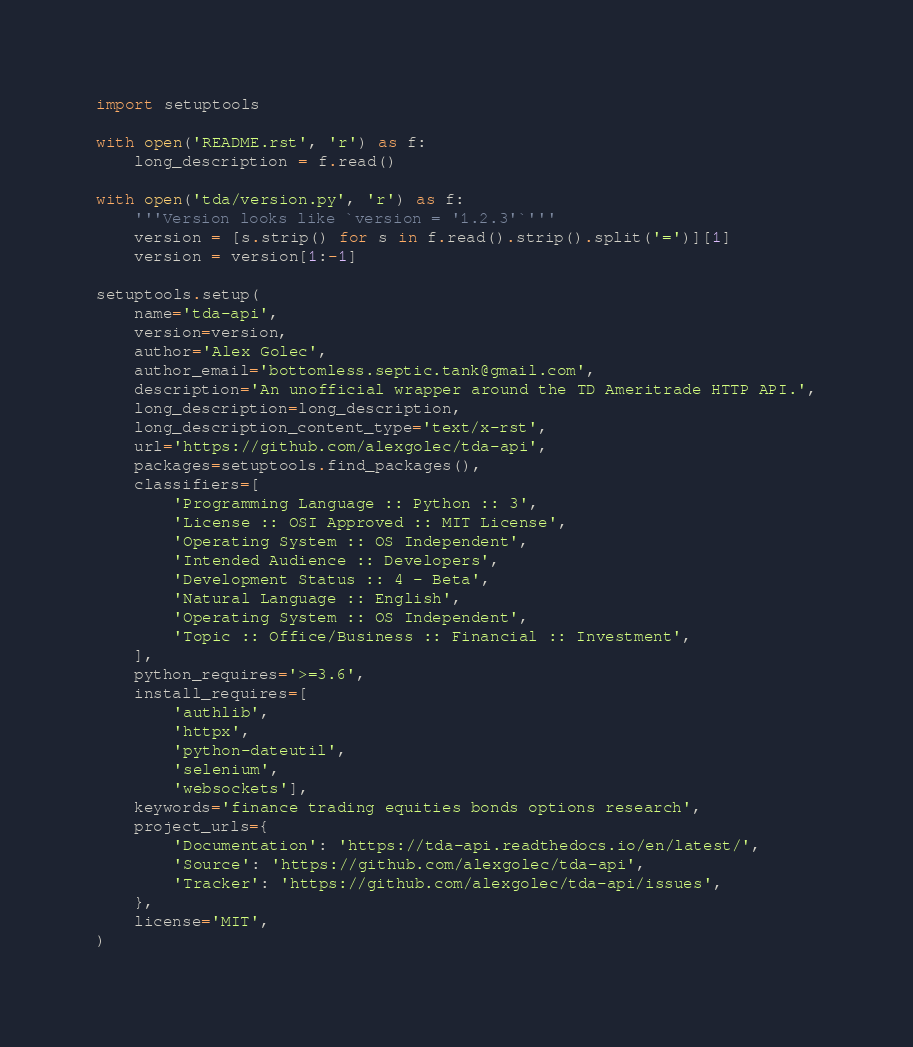Convert code to text. <code><loc_0><loc_0><loc_500><loc_500><_Python_>import setuptools

with open('README.rst', 'r') as f:
    long_description = f.read()

with open('tda/version.py', 'r') as f:
    '''Version looks like `version = '1.2.3'`'''
    version = [s.strip() for s in f.read().strip().split('=')][1]
    version = version[1:-1]

setuptools.setup(
    name='tda-api',
    version=version,
    author='Alex Golec',
    author_email='bottomless.septic.tank@gmail.com',
    description='An unofficial wrapper around the TD Ameritrade HTTP API.',
    long_description=long_description,
    long_description_content_type='text/x-rst',
    url='https://github.com/alexgolec/tda-api',
    packages=setuptools.find_packages(),
    classifiers=[
        'Programming Language :: Python :: 3',
        'License :: OSI Approved :: MIT License',
        'Operating System :: OS Independent',
        'Intended Audience :: Developers',
        'Development Status :: 4 - Beta',
        'Natural Language :: English',
        'Operating System :: OS Independent',
        'Topic :: Office/Business :: Financial :: Investment',
    ],
    python_requires='>=3.6',
    install_requires=[
        'authlib',
        'httpx',
        'python-dateutil',
        'selenium', 
        'websockets'],
    keywords='finance trading equities bonds options research',
    project_urls={
        'Documentation': 'https://tda-api.readthedocs.io/en/latest/',
        'Source': 'https://github.com/alexgolec/tda-api',
        'Tracker': 'https://github.com/alexgolec/tda-api/issues',
    },
    license='MIT',
)

</code> 